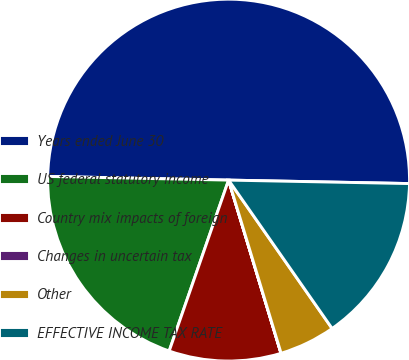<chart> <loc_0><loc_0><loc_500><loc_500><pie_chart><fcel>Years ended June 30<fcel>US federal statutory income<fcel>Country mix impacts of foreign<fcel>Changes in uncertain tax<fcel>Other<fcel>EFFECTIVE INCOME TAX RATE<nl><fcel>49.98%<fcel>20.0%<fcel>10.0%<fcel>0.01%<fcel>5.01%<fcel>15.0%<nl></chart> 